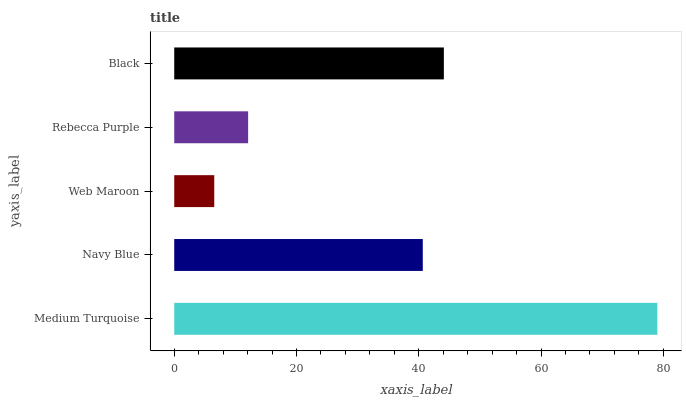Is Web Maroon the minimum?
Answer yes or no. Yes. Is Medium Turquoise the maximum?
Answer yes or no. Yes. Is Navy Blue the minimum?
Answer yes or no. No. Is Navy Blue the maximum?
Answer yes or no. No. Is Medium Turquoise greater than Navy Blue?
Answer yes or no. Yes. Is Navy Blue less than Medium Turquoise?
Answer yes or no. Yes. Is Navy Blue greater than Medium Turquoise?
Answer yes or no. No. Is Medium Turquoise less than Navy Blue?
Answer yes or no. No. Is Navy Blue the high median?
Answer yes or no. Yes. Is Navy Blue the low median?
Answer yes or no. Yes. Is Web Maroon the high median?
Answer yes or no. No. Is Black the low median?
Answer yes or no. No. 